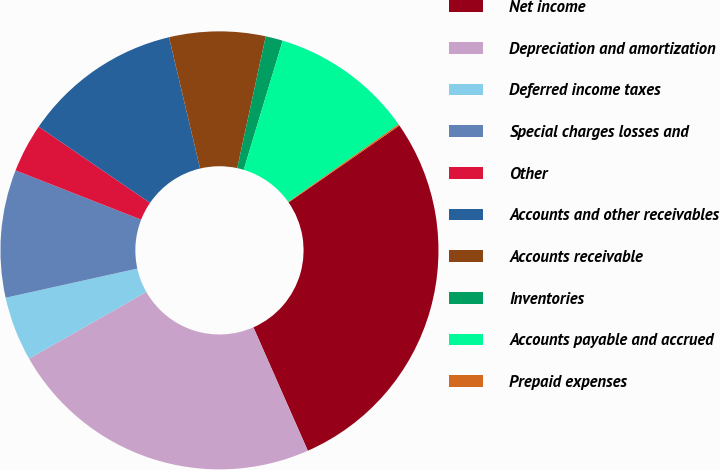Convert chart to OTSL. <chart><loc_0><loc_0><loc_500><loc_500><pie_chart><fcel>Net income<fcel>Depreciation and amortization<fcel>Deferred income taxes<fcel>Special charges losses and<fcel>Other<fcel>Accounts and other receivables<fcel>Accounts receivable<fcel>Inventories<fcel>Accounts payable and accrued<fcel>Prepaid expenses<nl><fcel>28.04%<fcel>23.38%<fcel>4.76%<fcel>9.42%<fcel>3.6%<fcel>11.75%<fcel>7.09%<fcel>1.27%<fcel>10.58%<fcel>0.11%<nl></chart> 